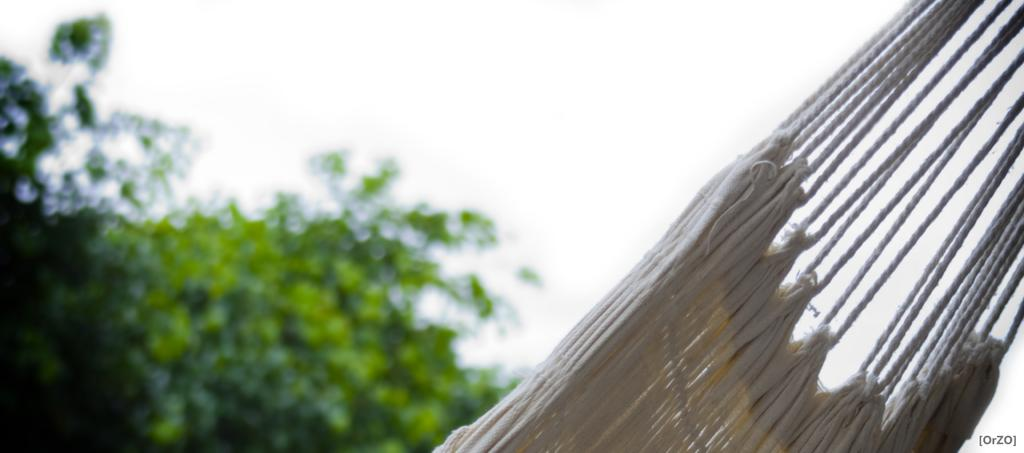What is the main object in the image? There is a hammock in the image. Can you describe the hammock in more detail? The sides of the hammock are visible in the image. What can be seen in the background of the image? There are green trees in the background of the image. What type of surprise can be seen in the lunchroom in the image? There is no lunchroom or surprise present in the image; it features a hammock with visible sides and green trees in the background. 